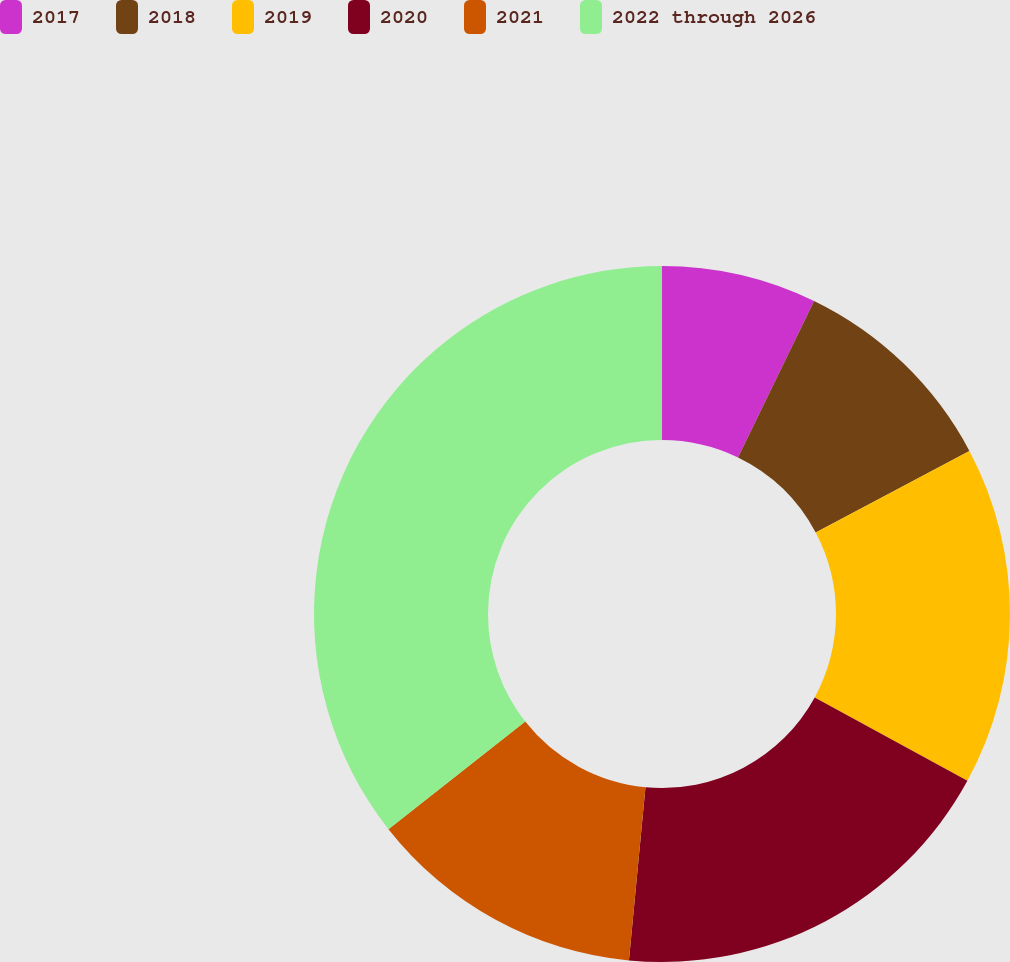<chart> <loc_0><loc_0><loc_500><loc_500><pie_chart><fcel>2017<fcel>2018<fcel>2019<fcel>2020<fcel>2021<fcel>2022 through 2026<nl><fcel>7.2%<fcel>10.04%<fcel>15.72%<fcel>18.56%<fcel>12.88%<fcel>35.61%<nl></chart> 